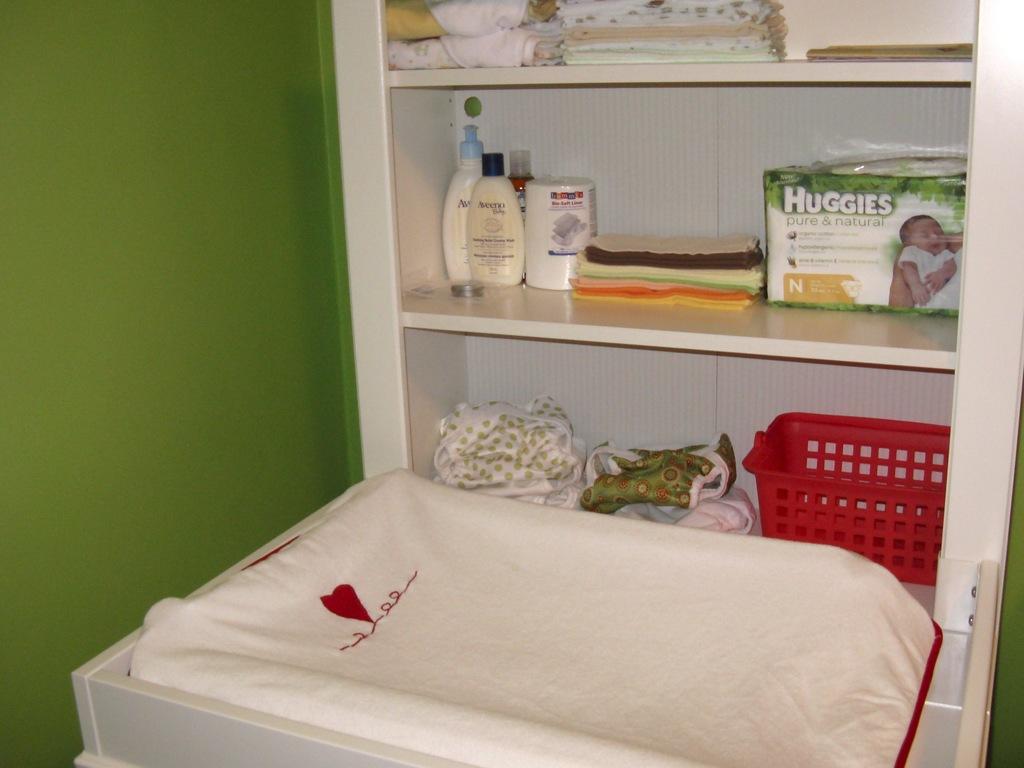What is the brand of diapers?
Offer a very short reply. Huggies. 